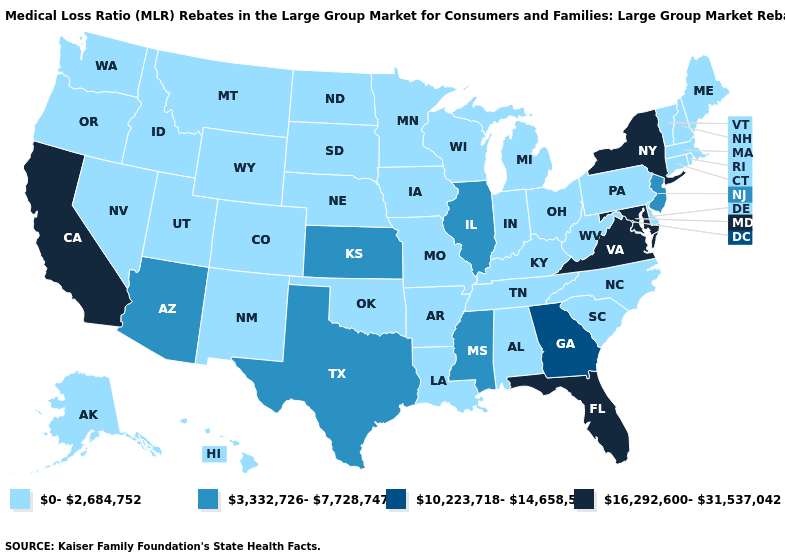What is the highest value in states that border Alabama?
Short answer required. 16,292,600-31,537,042. How many symbols are there in the legend?
Short answer required. 4. What is the value of Pennsylvania?
Concise answer only. 0-2,684,752. What is the lowest value in the West?
Quick response, please. 0-2,684,752. Name the states that have a value in the range 0-2,684,752?
Keep it brief. Alabama, Alaska, Arkansas, Colorado, Connecticut, Delaware, Hawaii, Idaho, Indiana, Iowa, Kentucky, Louisiana, Maine, Massachusetts, Michigan, Minnesota, Missouri, Montana, Nebraska, Nevada, New Hampshire, New Mexico, North Carolina, North Dakota, Ohio, Oklahoma, Oregon, Pennsylvania, Rhode Island, South Carolina, South Dakota, Tennessee, Utah, Vermont, Washington, West Virginia, Wisconsin, Wyoming. What is the value of Alaska?
Be succinct. 0-2,684,752. Among the states that border Florida , which have the highest value?
Be succinct. Georgia. Does New York have the lowest value in the Northeast?
Give a very brief answer. No. Among the states that border Wisconsin , which have the highest value?
Quick response, please. Illinois. Does the map have missing data?
Answer briefly. No. What is the value of Missouri?
Write a very short answer. 0-2,684,752. Which states have the lowest value in the USA?
Answer briefly. Alabama, Alaska, Arkansas, Colorado, Connecticut, Delaware, Hawaii, Idaho, Indiana, Iowa, Kentucky, Louisiana, Maine, Massachusetts, Michigan, Minnesota, Missouri, Montana, Nebraska, Nevada, New Hampshire, New Mexico, North Carolina, North Dakota, Ohio, Oklahoma, Oregon, Pennsylvania, Rhode Island, South Carolina, South Dakota, Tennessee, Utah, Vermont, Washington, West Virginia, Wisconsin, Wyoming. Does California have the lowest value in the West?
Concise answer only. No. Name the states that have a value in the range 10,223,718-14,658,558?
Short answer required. Georgia. Does Texas have the lowest value in the USA?
Write a very short answer. No. 